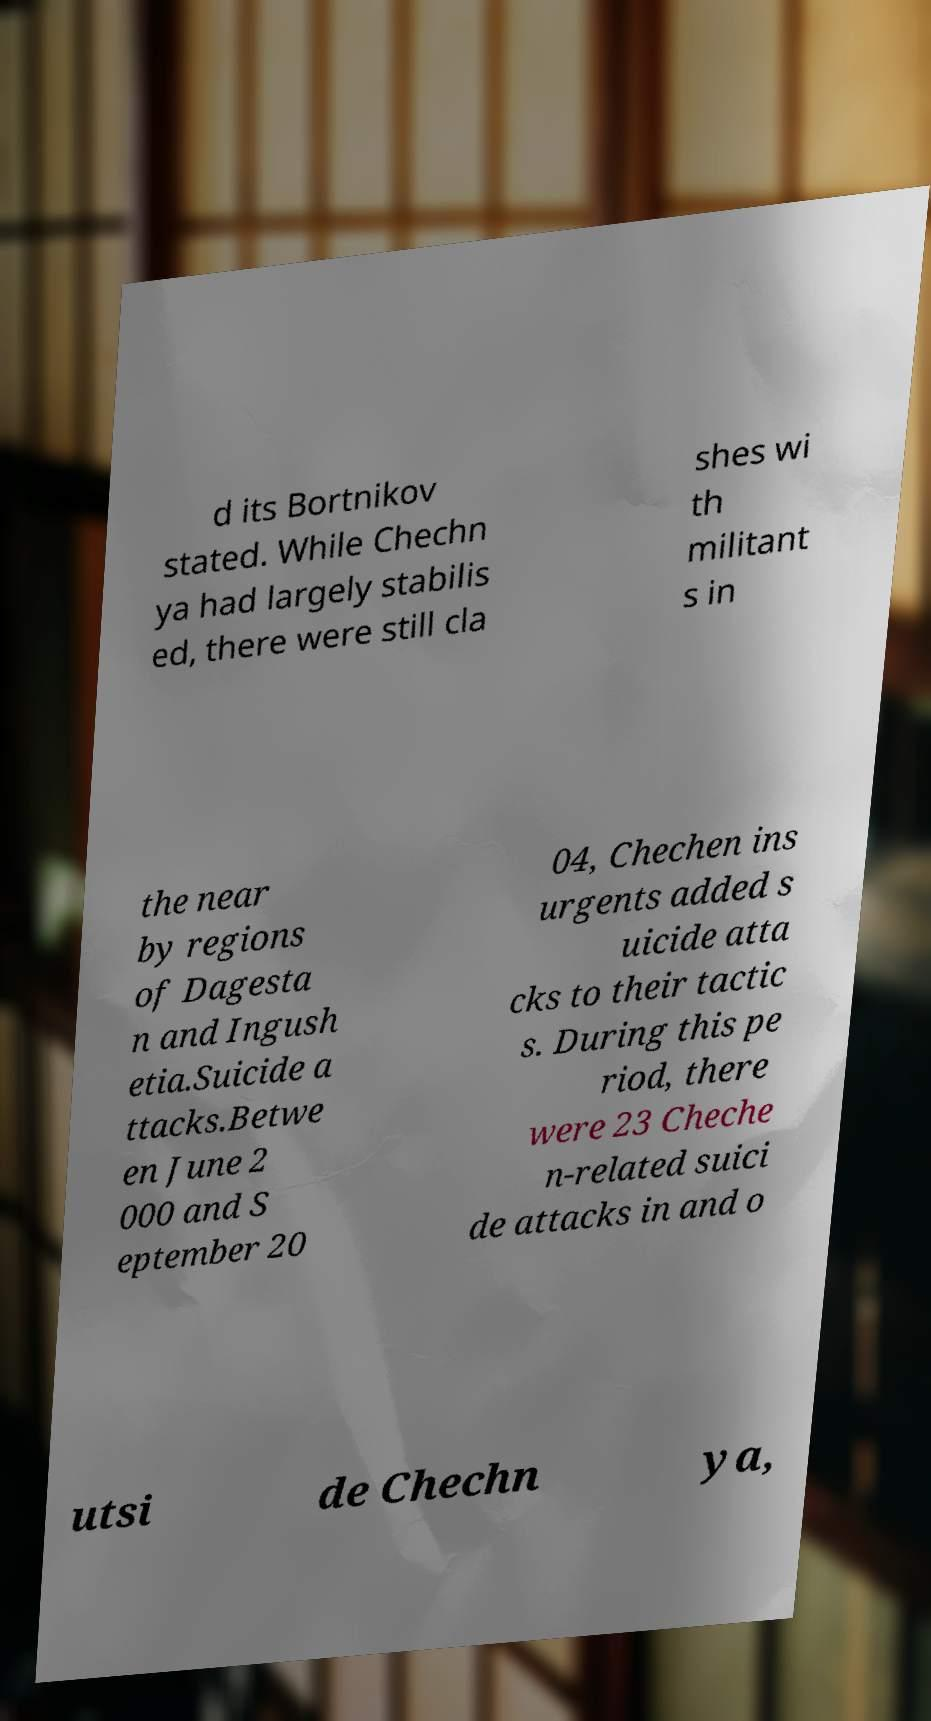What messages or text are displayed in this image? I need them in a readable, typed format. d its Bortnikov stated. While Chechn ya had largely stabilis ed, there were still cla shes wi th militant s in the near by regions of Dagesta n and Ingush etia.Suicide a ttacks.Betwe en June 2 000 and S eptember 20 04, Chechen ins urgents added s uicide atta cks to their tactic s. During this pe riod, there were 23 Cheche n-related suici de attacks in and o utsi de Chechn ya, 